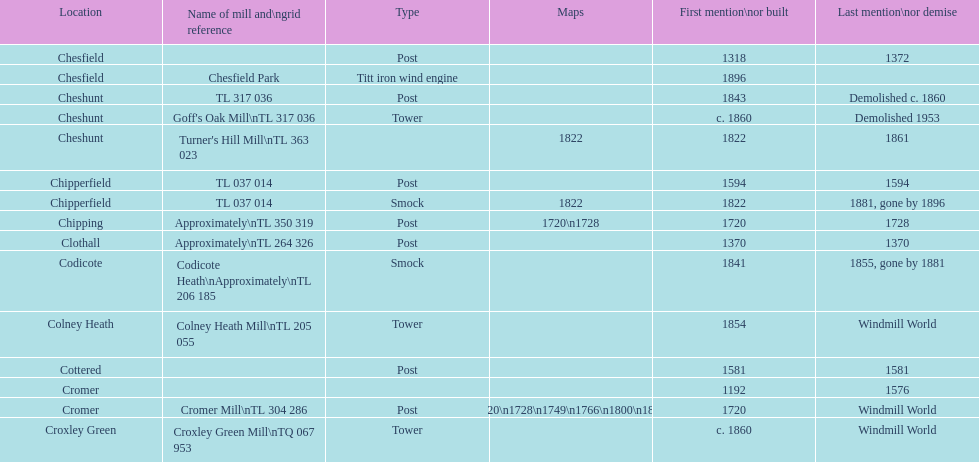What is the name of the only "c" mill located in colney health? Colney Heath Mill. 